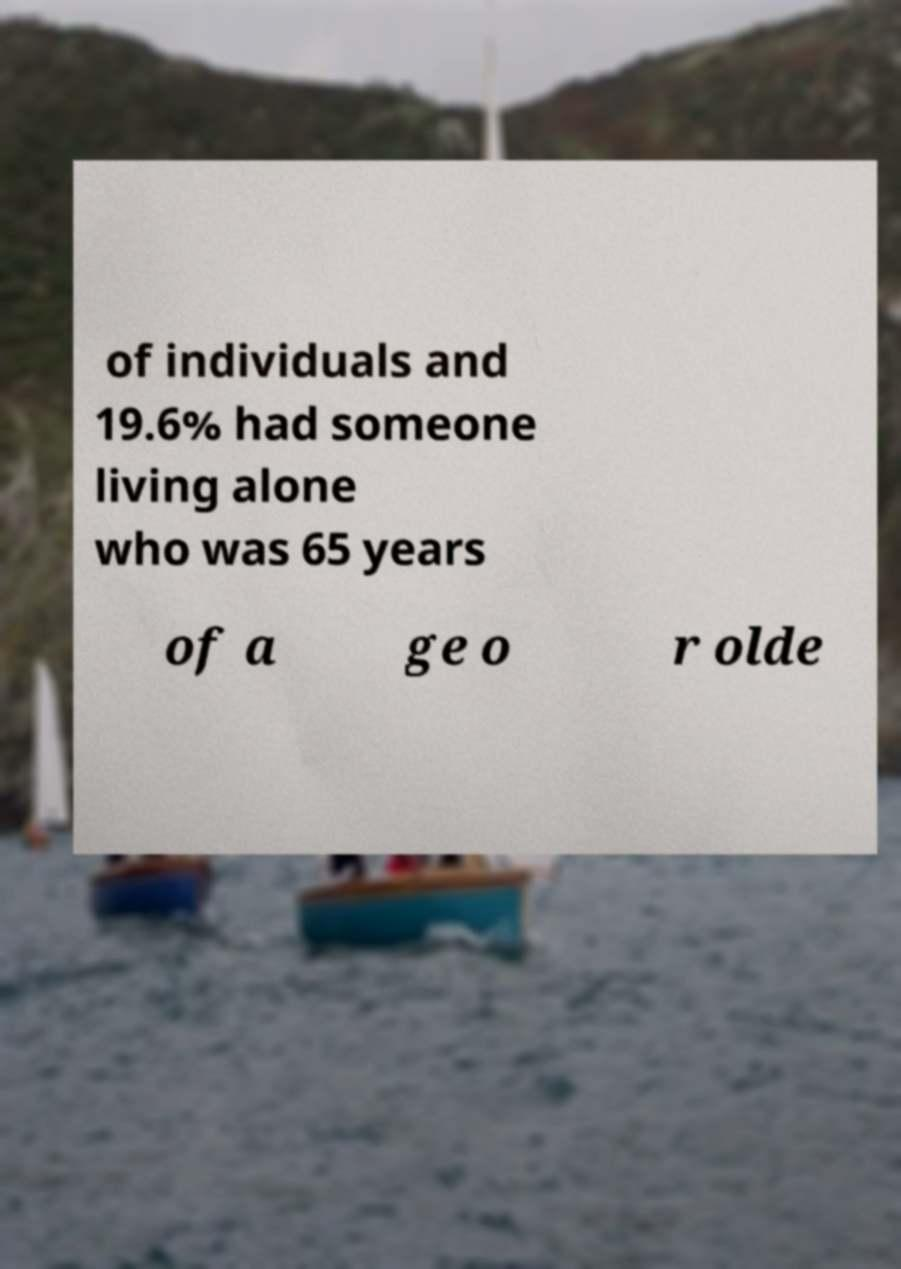There's text embedded in this image that I need extracted. Can you transcribe it verbatim? of individuals and 19.6% had someone living alone who was 65 years of a ge o r olde 